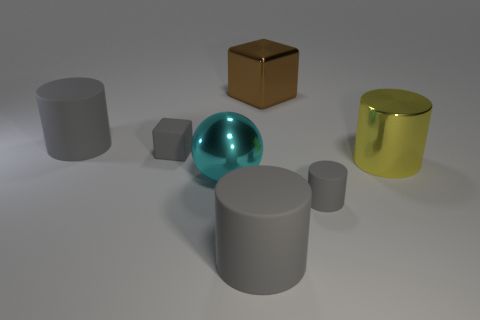There is a small matte object that is the same color as the rubber block; what shape is it?
Give a very brief answer. Cylinder. How many large gray rubber cylinders are behind the tiny gray matte thing that is to the right of the big gray matte cylinder in front of the tiny cube?
Offer a very short reply. 1. The metal ball that is the same size as the brown thing is what color?
Your answer should be very brief. Cyan. What is the size of the matte cylinder that is behind the big metal object to the right of the brown object?
Your answer should be compact. Large. What size is the rubber block that is the same color as the tiny cylinder?
Provide a short and direct response. Small. How many other objects are the same size as the yellow thing?
Ensure brevity in your answer.  4. How many metallic cubes are there?
Provide a succinct answer. 1. Is the size of the brown thing the same as the gray rubber cube?
Ensure brevity in your answer.  No. How many other objects are there of the same shape as the yellow thing?
Offer a terse response. 3. What is the material of the gray thing that is on the left side of the small rubber thing that is on the left side of the large metal ball?
Offer a terse response. Rubber. 